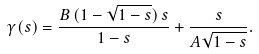Convert formula to latex. <formula><loc_0><loc_0><loc_500><loc_500>\gamma ( s ) = \frac { B \, ( 1 - \sqrt { 1 - s } ) \, s } { 1 - s } + \frac { s } { A \sqrt { 1 - s } } .</formula> 